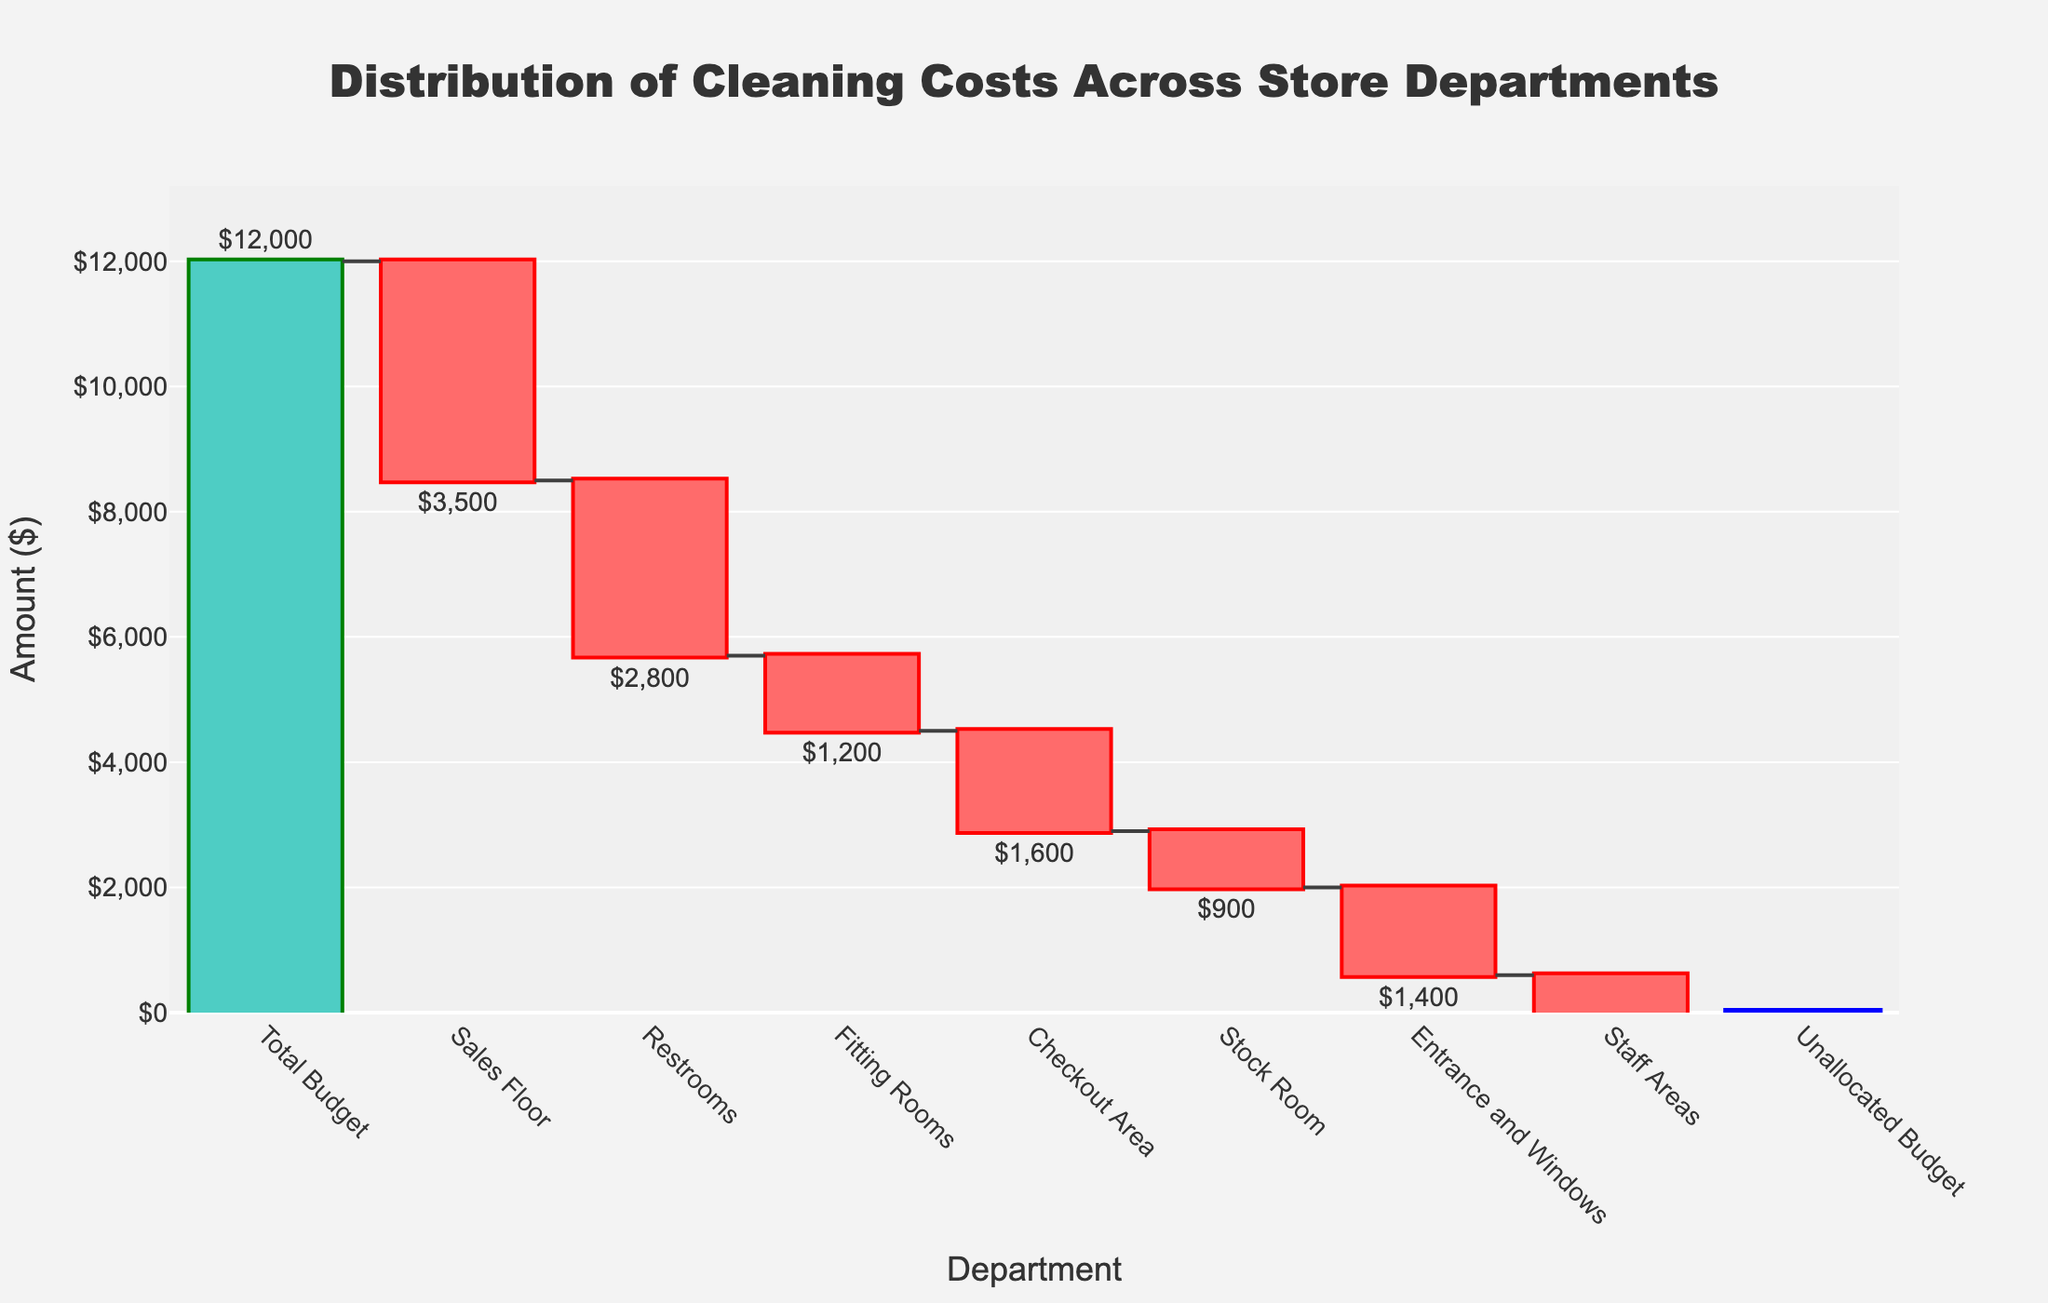What's the total budget for cleaning? The total budget is shown at the top of the chart and listed as "Total Budget" which is represented as the starting point of the Waterfall Chart.
Answer: $12,000 What's the cleaning cost for the Sales Floor? To find the cleaning cost for the Sales Floor, identify the respective bar labeled "Sales Floor" on the x-axis and refer to the text label found outside the bar indicating the amount.
Answer: $3,500 Which department has the highest cleaning cost? By comparing the lengths of the bars, the longest bar corresponds to the Sales Floor, indicating it has the highest cleaning cost. This is verified by the text label "$3,500" above the bar.
Answer: Sales Floor What's the cumulative cost of cleaning the Restrooms and the Fitting Rooms? To find the cumulative cost, gather the costs for the Restrooms and Fitting Rooms and sum them up: Restrooms is $2,800 and Fitting Rooms is $1,200. So, $2,800 + $1,200 = $4,000.
Answer: $4,000 What is the unallocated budget after accounting for all department costs? After summing all department costs, it is shown as the end point of the Waterfall Chart labeled "Unallocated Budget," which is 0.
Answer: $0 How does the cleaning cost of the Stock Room compare to the Check-out Area? Compare the two bars: the Checkout Area's cost is $1,600 and the Stock Room's cost is $900, so the Check-out Area has a higher cleaning cost.
Answer: Check-out Area is higher If the Total Budget is $12,000, what percentage of the budget is spent on the Entrance and Windows? The cleaning cost for Entrance and Windows is $1,400 and the total budget is $12,000. The percentage is calculated by (1,400 / 12,000) * 100. This equals approximately 11.67%.
Answer: 11.67% What's the total combined cost of cleaning the Checkout Area, Stock Room, and Staff Areas? Sum the costs of these departments: Checkout Area ($1,600) + Stock Room ($900) + Staff Areas ($800) = $3,300.
Answer: $3,300 Which department costs are represented by positive or increasing bars? In a Waterfall Chart, positive or increasing bars represent cost allocations from the Total Budget. By inspecting the chart, the decreasing bars represent expenditures, not increases. In this context, the Total Budget bar is the only increasing one.
Answer: Total Budget What is the average cleaning cost per department (excluding the total and unallocated budget)? Sum the costs of all departments: Sales Floor ($3,500) + Restrooms ($2,800) + Fitting Rooms ($1,200) + Checkout Area ($1,600) + Stock Room ($900) + Entrance and Windows ($1,400) + Staff Areas ($800). Then divide by the number of departments (7). The total is $12,200 divided by 7, which equals approximately $1,742.86.
Answer: $1,742.86 